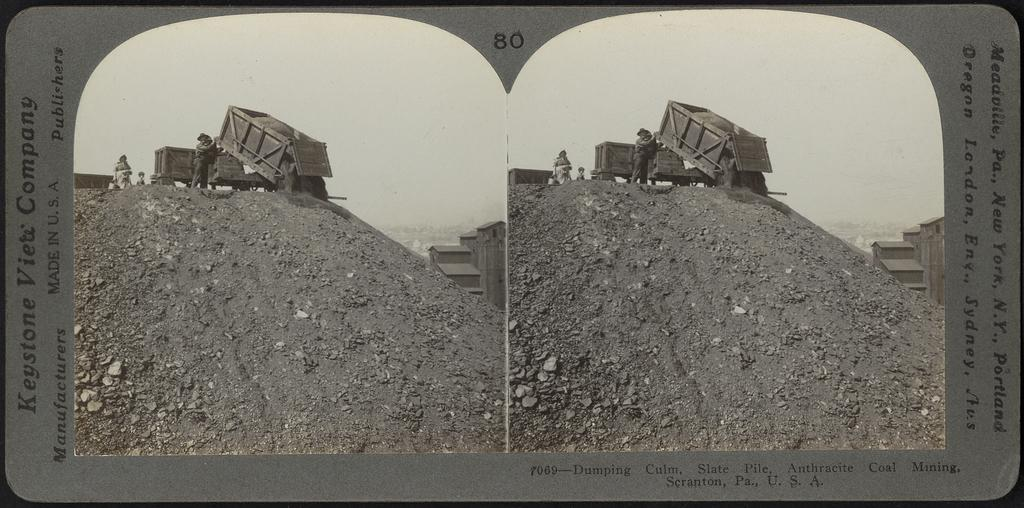<image>
Present a compact description of the photo's key features. Two picture of a quarry with the words Keystone Company along the side. 